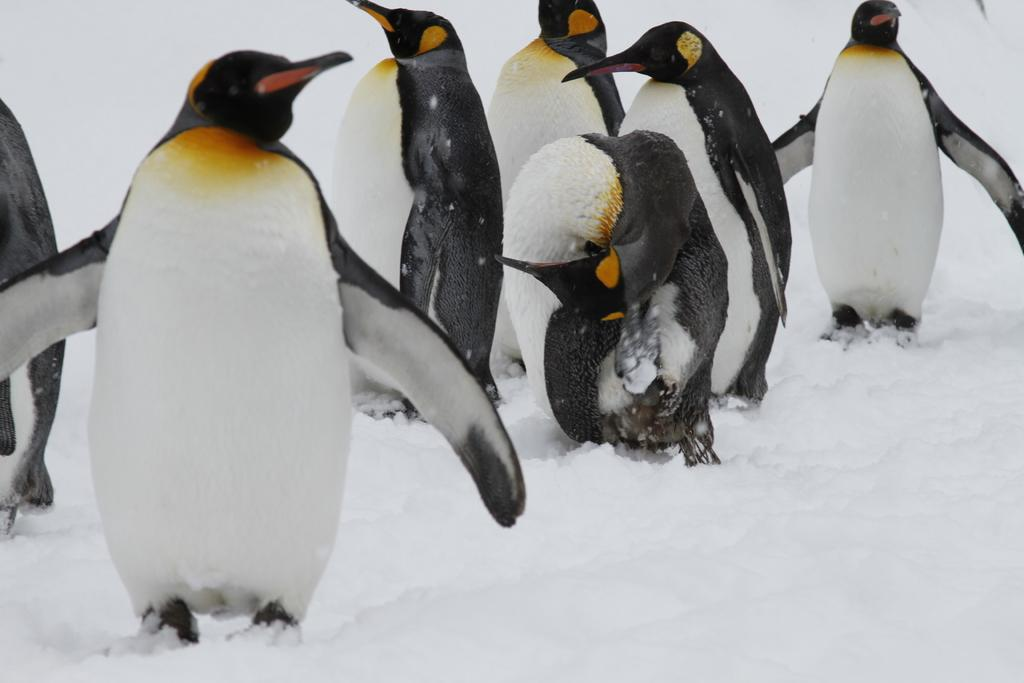What type of animals are in the image? There are penguins in the image. What is the surface on which the penguins are standing? The penguins are on the snow. What can be seen in the background of the image? The background of the image includes snow. What type of brush is being used by the penguins in the image? There is no brush present in the image; the penguins are simply standing on the snow. 